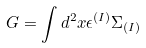<formula> <loc_0><loc_0><loc_500><loc_500>G = \int d ^ { 2 } x \epsilon ^ { ( I ) } \Sigma _ { ( I ) }</formula> 